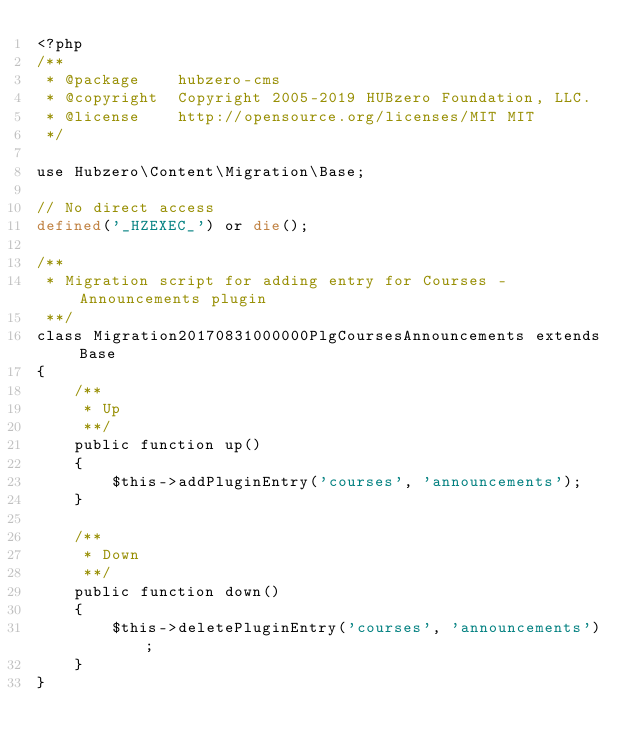Convert code to text. <code><loc_0><loc_0><loc_500><loc_500><_PHP_><?php
/**
 * @package    hubzero-cms
 * @copyright  Copyright 2005-2019 HUBzero Foundation, LLC.
 * @license    http://opensource.org/licenses/MIT MIT
 */

use Hubzero\Content\Migration\Base;

// No direct access
defined('_HZEXEC_') or die();

/**
 * Migration script for adding entry for Courses - Announcements plugin
 **/
class Migration20170831000000PlgCoursesAnnouncements extends Base
{
	/**
	 * Up
	 **/
	public function up()
	{
		$this->addPluginEntry('courses', 'announcements');
	}

	/**
	 * Down
	 **/
	public function down()
	{
		$this->deletePluginEntry('courses', 'announcements');
	}
}
</code> 